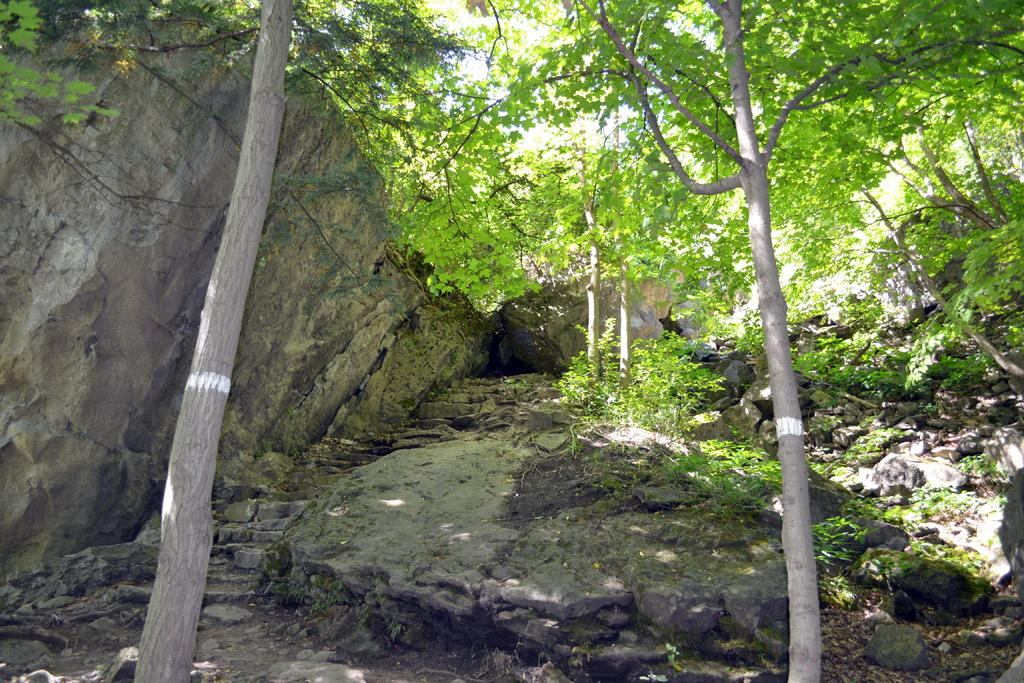What type of vegetation can be seen in the image? There are trees in the image. What type of natural feature can be seen on the path in the image? There are rocks on a path in the image. What type of smell can be detected from the trees in the image? There is no information about the smell of the trees in the image, so it cannot be determined. 